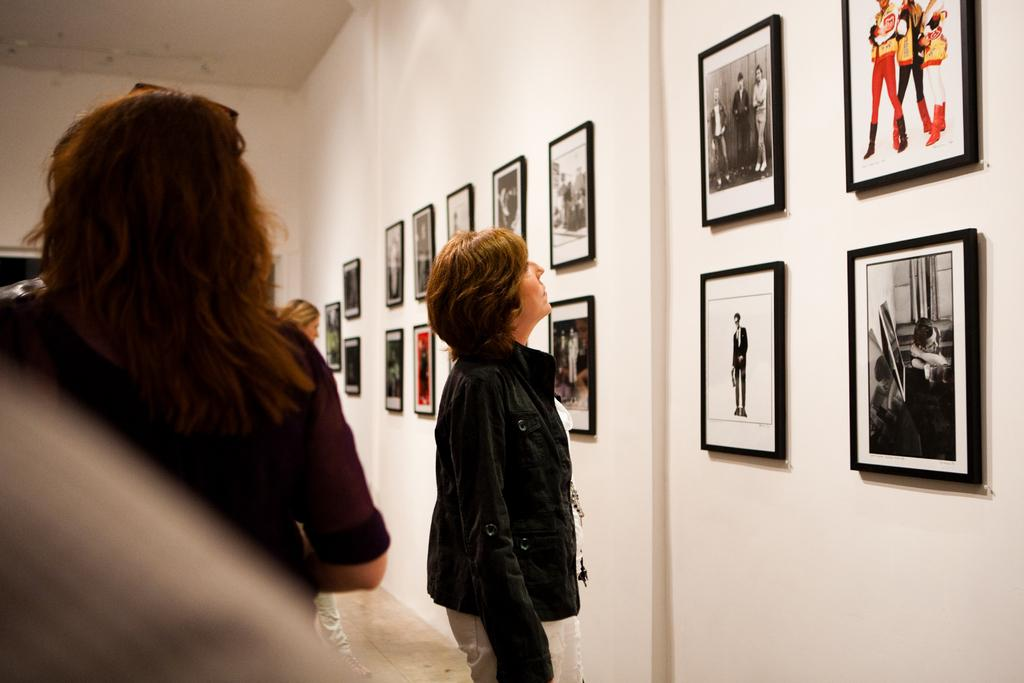How many people are in the image? There are few persons in the image. What can be seen on the right side of the image? There is a wall with photo frames on the right side of the image. What is at the bottom of the image? There is a floor at the bottom of the image. What is at the top of the image? There is a roof at the top of the image. How many boats are visible in the image? There are no boats present in the image. What type of cows can be seen grazing in the background of the image? There is no background or cows visible in the image. 